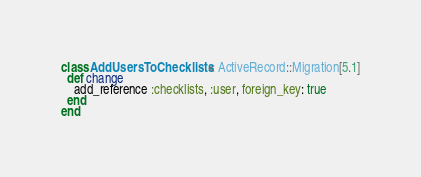<code> <loc_0><loc_0><loc_500><loc_500><_Ruby_>class AddUsersToChecklists < ActiveRecord::Migration[5.1]
  def change
    add_reference :checklists, :user, foreign_key: true
  end
end
</code> 